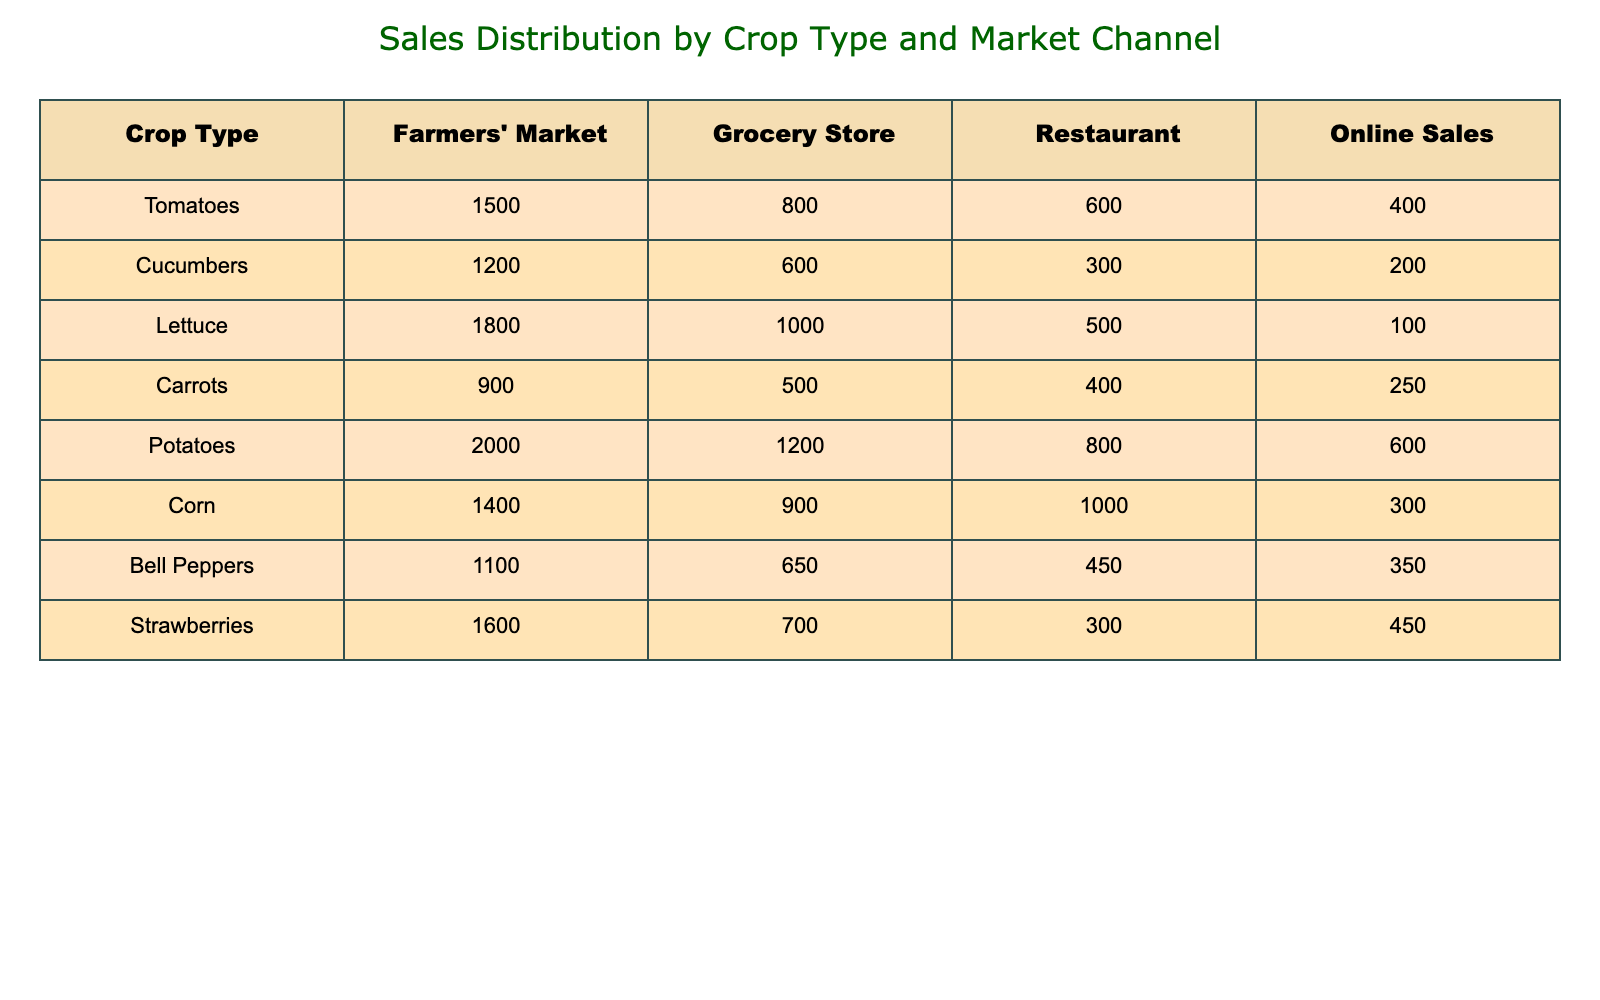What is the highest number of sales for a single crop type in the Farmers' Market? Looking at the Farmers' Market column, the highest number of sales is for Potatoes, which have 2000 sales.
Answer: 2000 Which crop type has the lowest sales in the Grocery Store? In the Grocery Store column, the lowest sales are for Cucumbers, with 600 sales.
Answer: 600 How many more tomatoes were sold in the Farmers' Market compared to online sales? For Tomatoes, there are 1500 sales in the Farmers' Market and 400 in online sales. The difference is 1500 - 400 = 1100.
Answer: 1100 What is the total sales of Carrots across all market channels? The sales of Carrots are 900 (Farmers' Market) + 500 (Grocery Store) + 400 (Restaurant) + 250 (Online) = 2050.
Answer: 2050 Is the sales figure for Bell Peppers in the Restaurant higher than that of Strawberries? For Bell Peppers, the sales are 450, while for Strawberries, they are 300. Since 450 is greater than 300, the statement is true.
Answer: Yes What percentage of total sales for Potatoes come from Online Sales? The total sales for Potatoes are 2000 + 1200 + 800 + 600 = 3600. Online Sales are 600. The percentage of Online Sales is (600/3600) * 100 = 16.67%.
Answer: 16.67 Which crop type has the highest sales in the Restaurant market channel? In the Restaurant column, Corn has the highest sales with 1000, compared to other crops.
Answer: Corn What is the average number of units sold across all market channels for Lettuce? Sales for Lettuce are 1800 (Farmers' Market) + 1000 (Grocery Store) + 500 (Restaurant) + 100 (Online) = 3400. There are 4 market channels, so the average is 3400 / 4 = 850.
Answer: 850 